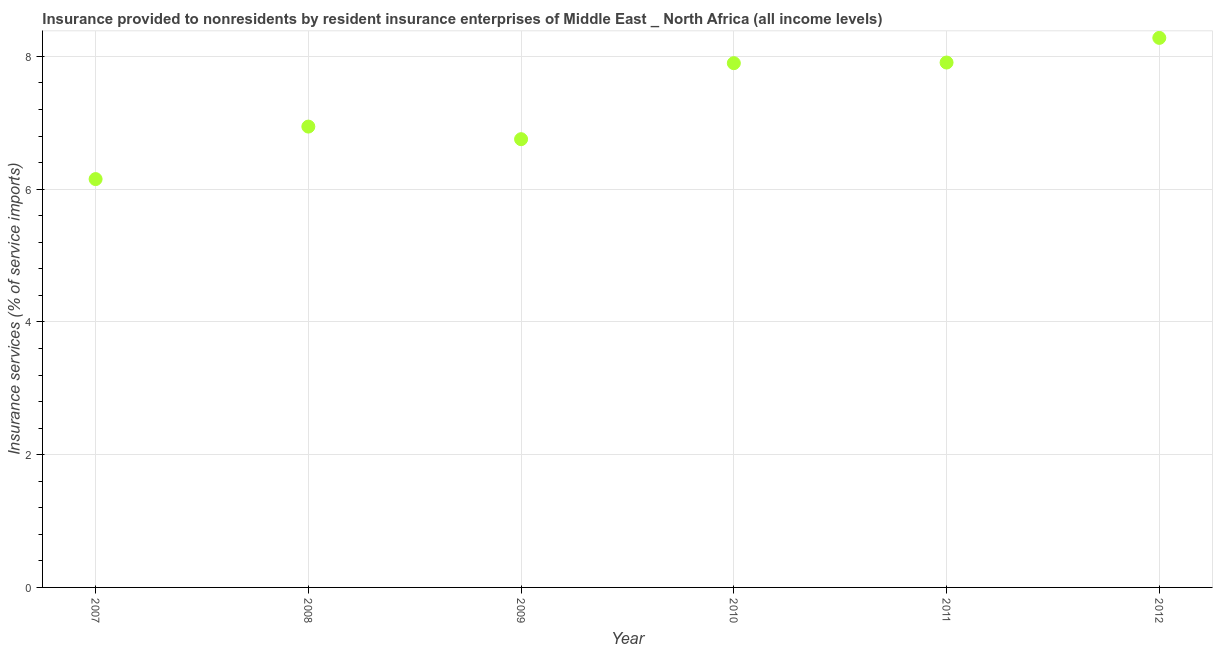What is the insurance and financial services in 2012?
Give a very brief answer. 8.28. Across all years, what is the maximum insurance and financial services?
Ensure brevity in your answer.  8.28. Across all years, what is the minimum insurance and financial services?
Your answer should be very brief. 6.15. In which year was the insurance and financial services maximum?
Offer a terse response. 2012. In which year was the insurance and financial services minimum?
Your answer should be very brief. 2007. What is the sum of the insurance and financial services?
Make the answer very short. 43.93. What is the difference between the insurance and financial services in 2010 and 2012?
Your answer should be very brief. -0.38. What is the average insurance and financial services per year?
Your answer should be very brief. 7.32. What is the median insurance and financial services?
Ensure brevity in your answer.  7.42. In how many years, is the insurance and financial services greater than 3.6 %?
Offer a very short reply. 6. Do a majority of the years between 2011 and 2012 (inclusive) have insurance and financial services greater than 2.4 %?
Provide a succinct answer. Yes. What is the ratio of the insurance and financial services in 2010 to that in 2012?
Offer a terse response. 0.95. What is the difference between the highest and the second highest insurance and financial services?
Offer a terse response. 0.37. Is the sum of the insurance and financial services in 2009 and 2012 greater than the maximum insurance and financial services across all years?
Provide a short and direct response. Yes. What is the difference between the highest and the lowest insurance and financial services?
Ensure brevity in your answer.  2.13. In how many years, is the insurance and financial services greater than the average insurance and financial services taken over all years?
Give a very brief answer. 3. Does the insurance and financial services monotonically increase over the years?
Provide a succinct answer. No. How many years are there in the graph?
Offer a terse response. 6. What is the difference between two consecutive major ticks on the Y-axis?
Ensure brevity in your answer.  2. Are the values on the major ticks of Y-axis written in scientific E-notation?
Your answer should be very brief. No. What is the title of the graph?
Ensure brevity in your answer.  Insurance provided to nonresidents by resident insurance enterprises of Middle East _ North Africa (all income levels). What is the label or title of the X-axis?
Provide a short and direct response. Year. What is the label or title of the Y-axis?
Provide a succinct answer. Insurance services (% of service imports). What is the Insurance services (% of service imports) in 2007?
Your answer should be very brief. 6.15. What is the Insurance services (% of service imports) in 2008?
Your answer should be compact. 6.94. What is the Insurance services (% of service imports) in 2009?
Provide a short and direct response. 6.75. What is the Insurance services (% of service imports) in 2010?
Your answer should be compact. 7.9. What is the Insurance services (% of service imports) in 2011?
Your answer should be very brief. 7.91. What is the Insurance services (% of service imports) in 2012?
Your answer should be compact. 8.28. What is the difference between the Insurance services (% of service imports) in 2007 and 2008?
Provide a succinct answer. -0.79. What is the difference between the Insurance services (% of service imports) in 2007 and 2009?
Offer a terse response. -0.6. What is the difference between the Insurance services (% of service imports) in 2007 and 2010?
Your response must be concise. -1.75. What is the difference between the Insurance services (% of service imports) in 2007 and 2011?
Give a very brief answer. -1.76. What is the difference between the Insurance services (% of service imports) in 2007 and 2012?
Ensure brevity in your answer.  -2.13. What is the difference between the Insurance services (% of service imports) in 2008 and 2009?
Provide a succinct answer. 0.19. What is the difference between the Insurance services (% of service imports) in 2008 and 2010?
Your answer should be compact. -0.96. What is the difference between the Insurance services (% of service imports) in 2008 and 2011?
Offer a very short reply. -0.97. What is the difference between the Insurance services (% of service imports) in 2008 and 2012?
Your response must be concise. -1.34. What is the difference between the Insurance services (% of service imports) in 2009 and 2010?
Ensure brevity in your answer.  -1.15. What is the difference between the Insurance services (% of service imports) in 2009 and 2011?
Offer a very short reply. -1.15. What is the difference between the Insurance services (% of service imports) in 2009 and 2012?
Provide a succinct answer. -1.53. What is the difference between the Insurance services (% of service imports) in 2010 and 2011?
Keep it short and to the point. -0.01. What is the difference between the Insurance services (% of service imports) in 2010 and 2012?
Offer a terse response. -0.38. What is the difference between the Insurance services (% of service imports) in 2011 and 2012?
Provide a short and direct response. -0.37. What is the ratio of the Insurance services (% of service imports) in 2007 to that in 2008?
Provide a succinct answer. 0.89. What is the ratio of the Insurance services (% of service imports) in 2007 to that in 2009?
Your answer should be compact. 0.91. What is the ratio of the Insurance services (% of service imports) in 2007 to that in 2010?
Your answer should be very brief. 0.78. What is the ratio of the Insurance services (% of service imports) in 2007 to that in 2011?
Offer a terse response. 0.78. What is the ratio of the Insurance services (% of service imports) in 2007 to that in 2012?
Make the answer very short. 0.74. What is the ratio of the Insurance services (% of service imports) in 2008 to that in 2009?
Ensure brevity in your answer.  1.03. What is the ratio of the Insurance services (% of service imports) in 2008 to that in 2010?
Provide a short and direct response. 0.88. What is the ratio of the Insurance services (% of service imports) in 2008 to that in 2011?
Your answer should be compact. 0.88. What is the ratio of the Insurance services (% of service imports) in 2008 to that in 2012?
Your response must be concise. 0.84. What is the ratio of the Insurance services (% of service imports) in 2009 to that in 2010?
Provide a short and direct response. 0.85. What is the ratio of the Insurance services (% of service imports) in 2009 to that in 2011?
Give a very brief answer. 0.85. What is the ratio of the Insurance services (% of service imports) in 2009 to that in 2012?
Keep it short and to the point. 0.82. What is the ratio of the Insurance services (% of service imports) in 2010 to that in 2012?
Your answer should be compact. 0.95. What is the ratio of the Insurance services (% of service imports) in 2011 to that in 2012?
Your answer should be very brief. 0.95. 